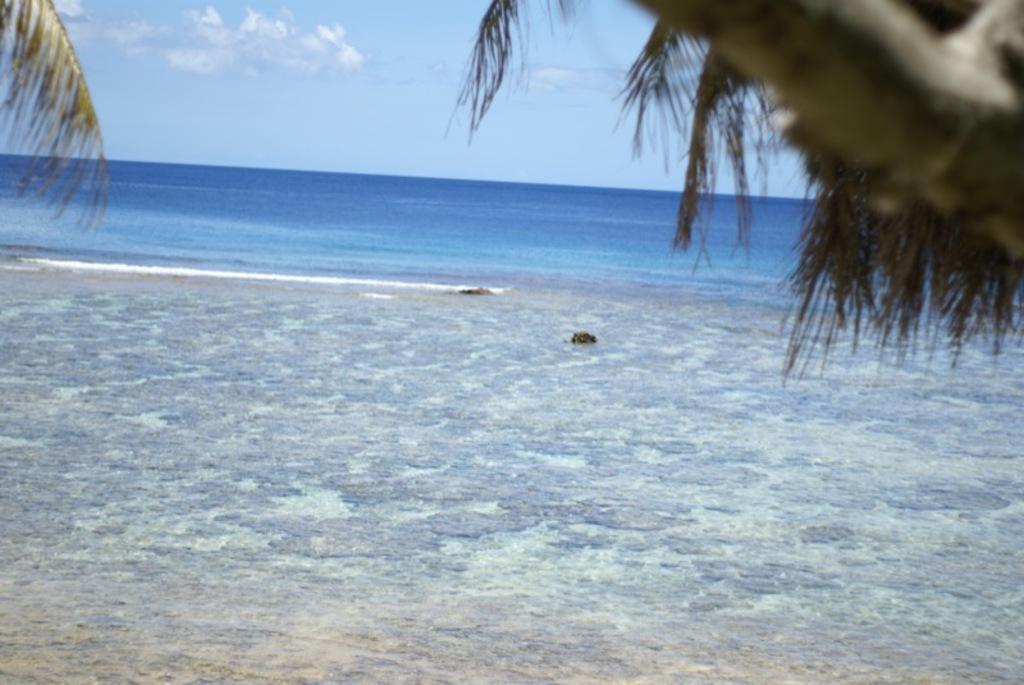How would you summarize this image in a sentence or two? There is sea. At the top there are leaves. In the back there is sky. 